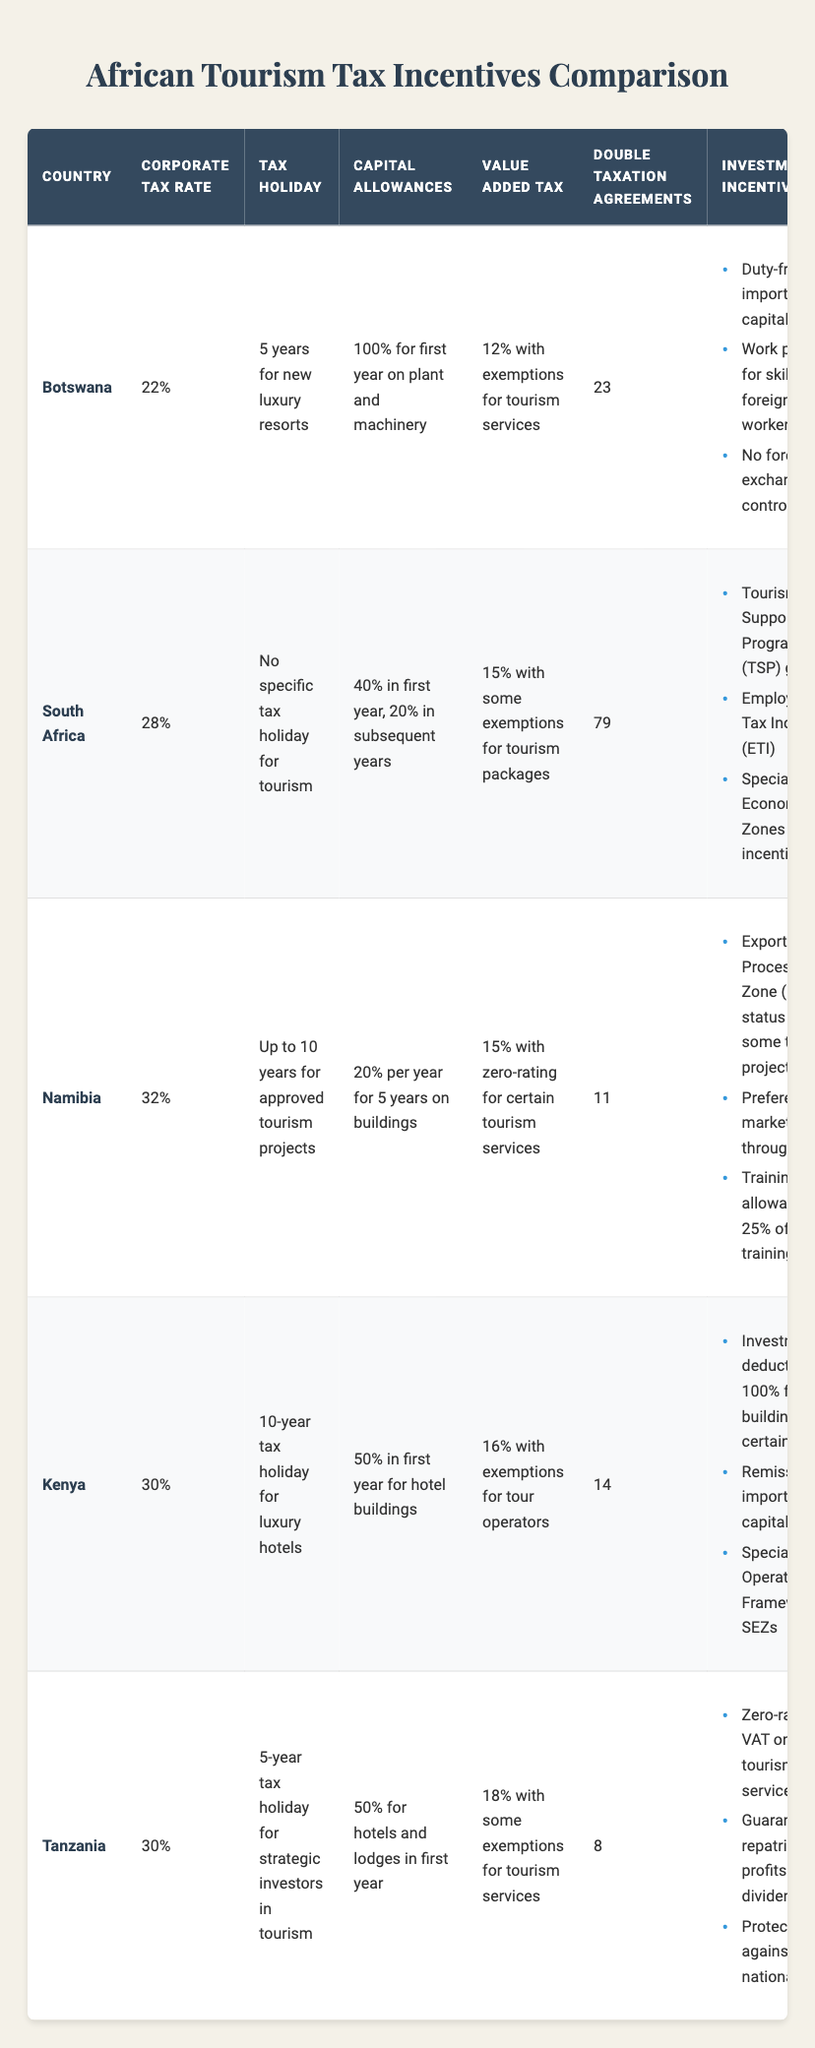What is the corporate tax rate in Botswana? The table states that the corporate tax rate in Botswana is listed directly under the "Corporate Tax Rate" column.
Answer: 22% Which country has the longest tax holiday for tourism? By examining the "Tax Holiday" column in the table, Namibia offers a tax holiday of up to 10 years for approved tourism projects, which is longer than any other country listed.
Answer: Namibia What is the average corporate tax rate among the countries listed? The corporate tax rates are as follows: Botswana (22%), South Africa (28%), Namibia (32%), Kenya (30%), and Tanzania (30%). Summing these gives (22 + 28 + 32 + 30 + 30) = 142. Dividing by 5 (the number of countries) gives 142 / 5 = 28.4.
Answer: 28.4% Does South Africa offer any specific tax holiday for tourism? Looking at the "Tax Holiday" column for South Africa, it clearly states "No specific tax holiday for tourism," indicating that the statement is false.
Answer: No Which country has the highest number of double taxation agreements? The values in the "Double Taxation Agreements" column show South Africa has 79 agreements, which is higher than all other countries in the table.
Answer: South Africa Are capital allowances in Botswana better than those in Kenya? In Botswana, the capital allowance is 100% for the first year on plant and machinery, while in Kenya, it is 50% in the first year for hotel buildings. Since 100% is better than 50%, the capital allowances in Botswana are indeed better.
Answer: Yes What are the investment incentives in Namibia? The table lists the following investment incentives under Namibia: "Export Processing Zone (EPZ) status for some tourism projects," "Preferential market access through SADC," and "Training allowance of 25% of training costs."
Answer: EPZ status, SADC access, training allowance Which country has the highest VAT rate among the listed countries? By referring to the "Value Added Tax" column, Tanzania has the highest VAT rate at 18%, compared to other countries listed that have lower rates.
Answer: Tanzania If an investor applies for a tourism project in Tanzania, what is the length of the tax holiday? In the "Tax Holiday" column for Tanzania, it specifies a "5-year tax holiday for strategic investors in tourism."
Answer: 5 years 